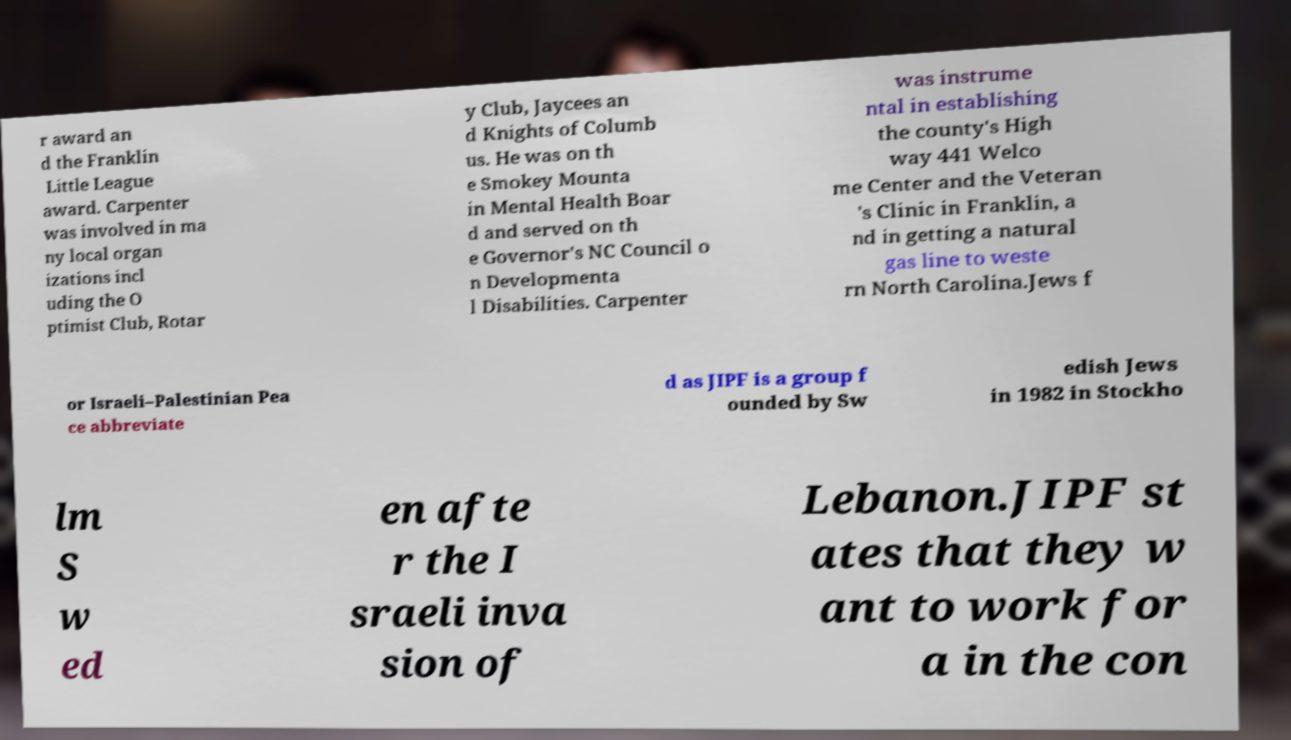There's text embedded in this image that I need extracted. Can you transcribe it verbatim? r award an d the Franklin Little League award. Carpenter was involved in ma ny local organ izations incl uding the O ptimist Club, Rotar y Club, Jaycees an d Knights of Columb us. He was on th e Smokey Mounta in Mental Health Boar d and served on th e Governor's NC Council o n Developmenta l Disabilities. Carpenter was instrume ntal in establishing the county's High way 441 Welco me Center and the Veteran 's Clinic in Franklin, a nd in getting a natural gas line to weste rn North Carolina.Jews f or Israeli–Palestinian Pea ce abbreviate d as JIPF is a group f ounded by Sw edish Jews in 1982 in Stockho lm S w ed en afte r the I sraeli inva sion of Lebanon.JIPF st ates that they w ant to work for a in the con 